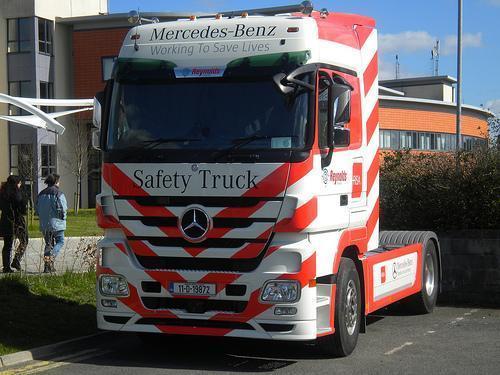How many tires can you see?
Give a very brief answer. 2. 